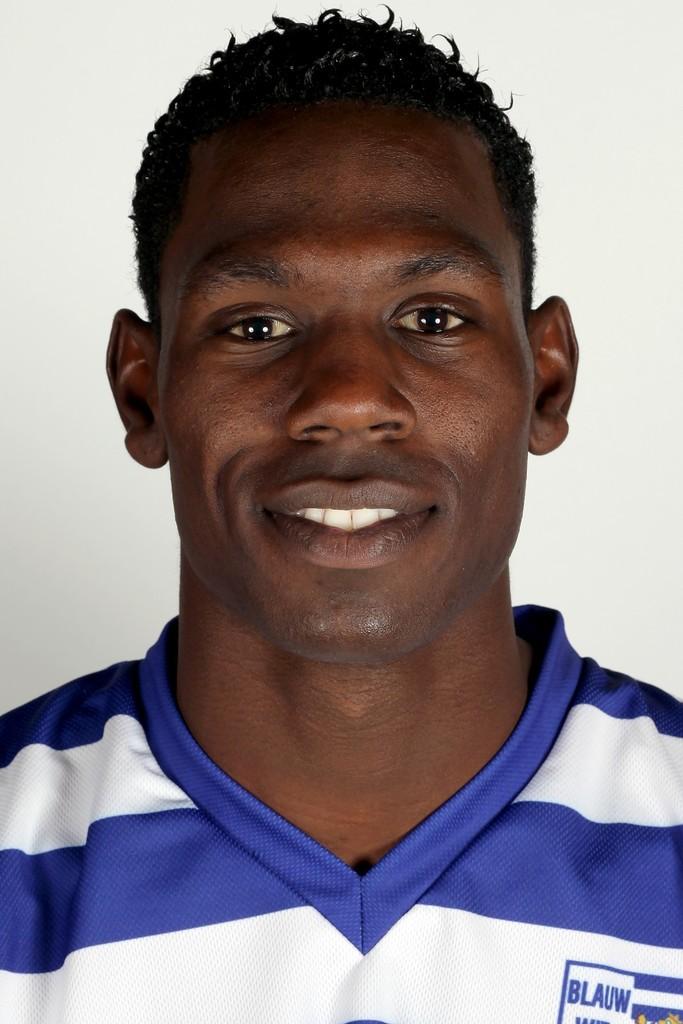What word is on the right of the shirt?
Provide a short and direct response. Blauw. 